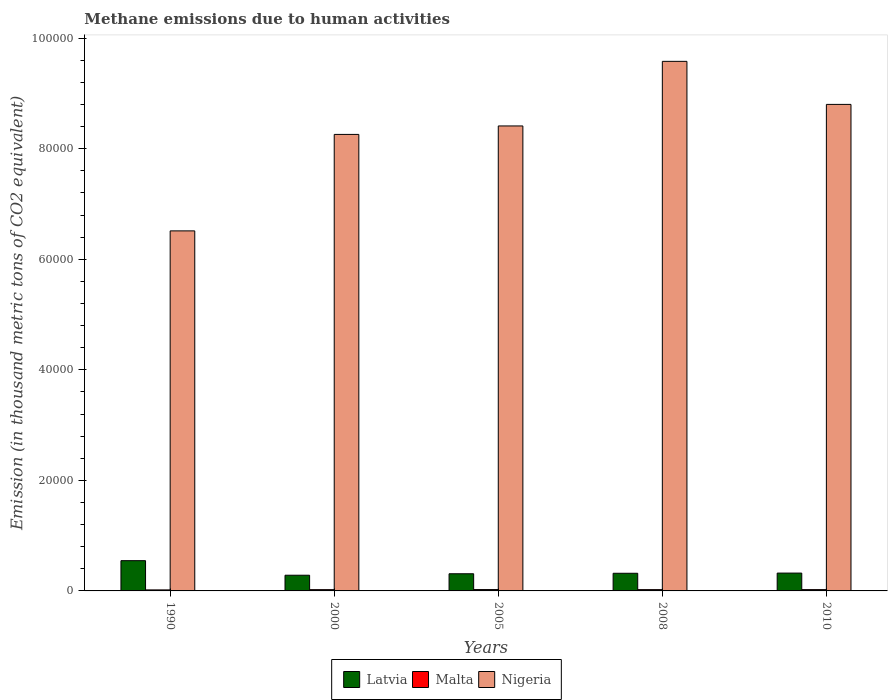How many different coloured bars are there?
Your answer should be very brief. 3. Are the number of bars per tick equal to the number of legend labels?
Offer a terse response. Yes. In how many cases, is the number of bars for a given year not equal to the number of legend labels?
Keep it short and to the point. 0. What is the amount of methane emitted in Malta in 2000?
Give a very brief answer. 230.8. Across all years, what is the maximum amount of methane emitted in Nigeria?
Give a very brief answer. 9.58e+04. Across all years, what is the minimum amount of methane emitted in Latvia?
Ensure brevity in your answer.  2840. In which year was the amount of methane emitted in Nigeria maximum?
Keep it short and to the point. 2008. In which year was the amount of methane emitted in Nigeria minimum?
Make the answer very short. 1990. What is the total amount of methane emitted in Nigeria in the graph?
Keep it short and to the point. 4.16e+05. What is the difference between the amount of methane emitted in Latvia in 2008 and that in 2010?
Your response must be concise. -35.3. What is the difference between the amount of methane emitted in Malta in 2005 and the amount of methane emitted in Latvia in 1990?
Your answer should be very brief. -5227.7. What is the average amount of methane emitted in Latvia per year?
Keep it short and to the point. 3567.46. In the year 2010, what is the difference between the amount of methane emitted in Latvia and amount of methane emitted in Malta?
Offer a very short reply. 2992. What is the ratio of the amount of methane emitted in Nigeria in 2008 to that in 2010?
Provide a succinct answer. 1.09. Is the difference between the amount of methane emitted in Latvia in 2005 and 2008 greater than the difference between the amount of methane emitted in Malta in 2005 and 2008?
Ensure brevity in your answer.  No. What is the difference between the highest and the second highest amount of methane emitted in Nigeria?
Your answer should be very brief. 7786.3. What is the difference between the highest and the lowest amount of methane emitted in Latvia?
Give a very brief answer. 2632.8. In how many years, is the amount of methane emitted in Latvia greater than the average amount of methane emitted in Latvia taken over all years?
Your response must be concise. 1. What does the 1st bar from the left in 2000 represents?
Offer a very short reply. Latvia. What does the 1st bar from the right in 2000 represents?
Offer a very short reply. Nigeria. Is it the case that in every year, the sum of the amount of methane emitted in Latvia and amount of methane emitted in Malta is greater than the amount of methane emitted in Nigeria?
Provide a short and direct response. No. Are all the bars in the graph horizontal?
Keep it short and to the point. No. How many years are there in the graph?
Ensure brevity in your answer.  5. What is the difference between two consecutive major ticks on the Y-axis?
Your answer should be compact. 2.00e+04. Are the values on the major ticks of Y-axis written in scientific E-notation?
Your answer should be compact. No. What is the title of the graph?
Give a very brief answer. Methane emissions due to human activities. What is the label or title of the Y-axis?
Your response must be concise. Emission (in thousand metric tons of CO2 equivalent). What is the Emission (in thousand metric tons of CO2 equivalent) in Latvia in 1990?
Your response must be concise. 5472.8. What is the Emission (in thousand metric tons of CO2 equivalent) of Malta in 1990?
Offer a very short reply. 183.7. What is the Emission (in thousand metric tons of CO2 equivalent) of Nigeria in 1990?
Your answer should be very brief. 6.51e+04. What is the Emission (in thousand metric tons of CO2 equivalent) of Latvia in 2000?
Your answer should be very brief. 2840. What is the Emission (in thousand metric tons of CO2 equivalent) of Malta in 2000?
Make the answer very short. 230.8. What is the Emission (in thousand metric tons of CO2 equivalent) in Nigeria in 2000?
Your response must be concise. 8.26e+04. What is the Emission (in thousand metric tons of CO2 equivalent) of Latvia in 2005?
Provide a succinct answer. 3105. What is the Emission (in thousand metric tons of CO2 equivalent) in Malta in 2005?
Your response must be concise. 245.1. What is the Emission (in thousand metric tons of CO2 equivalent) in Nigeria in 2005?
Give a very brief answer. 8.41e+04. What is the Emission (in thousand metric tons of CO2 equivalent) of Latvia in 2008?
Your answer should be very brief. 3192.1. What is the Emission (in thousand metric tons of CO2 equivalent) of Malta in 2008?
Provide a succinct answer. 234.5. What is the Emission (in thousand metric tons of CO2 equivalent) of Nigeria in 2008?
Give a very brief answer. 9.58e+04. What is the Emission (in thousand metric tons of CO2 equivalent) of Latvia in 2010?
Ensure brevity in your answer.  3227.4. What is the Emission (in thousand metric tons of CO2 equivalent) of Malta in 2010?
Offer a very short reply. 235.4. What is the Emission (in thousand metric tons of CO2 equivalent) of Nigeria in 2010?
Provide a succinct answer. 8.80e+04. Across all years, what is the maximum Emission (in thousand metric tons of CO2 equivalent) of Latvia?
Ensure brevity in your answer.  5472.8. Across all years, what is the maximum Emission (in thousand metric tons of CO2 equivalent) of Malta?
Offer a terse response. 245.1. Across all years, what is the maximum Emission (in thousand metric tons of CO2 equivalent) in Nigeria?
Keep it short and to the point. 9.58e+04. Across all years, what is the minimum Emission (in thousand metric tons of CO2 equivalent) in Latvia?
Make the answer very short. 2840. Across all years, what is the minimum Emission (in thousand metric tons of CO2 equivalent) of Malta?
Ensure brevity in your answer.  183.7. Across all years, what is the minimum Emission (in thousand metric tons of CO2 equivalent) in Nigeria?
Provide a short and direct response. 6.51e+04. What is the total Emission (in thousand metric tons of CO2 equivalent) in Latvia in the graph?
Provide a short and direct response. 1.78e+04. What is the total Emission (in thousand metric tons of CO2 equivalent) in Malta in the graph?
Your answer should be compact. 1129.5. What is the total Emission (in thousand metric tons of CO2 equivalent) in Nigeria in the graph?
Your answer should be compact. 4.16e+05. What is the difference between the Emission (in thousand metric tons of CO2 equivalent) in Latvia in 1990 and that in 2000?
Provide a short and direct response. 2632.8. What is the difference between the Emission (in thousand metric tons of CO2 equivalent) in Malta in 1990 and that in 2000?
Your answer should be compact. -47.1. What is the difference between the Emission (in thousand metric tons of CO2 equivalent) of Nigeria in 1990 and that in 2000?
Offer a very short reply. -1.75e+04. What is the difference between the Emission (in thousand metric tons of CO2 equivalent) in Latvia in 1990 and that in 2005?
Provide a short and direct response. 2367.8. What is the difference between the Emission (in thousand metric tons of CO2 equivalent) in Malta in 1990 and that in 2005?
Offer a very short reply. -61.4. What is the difference between the Emission (in thousand metric tons of CO2 equivalent) of Nigeria in 1990 and that in 2005?
Ensure brevity in your answer.  -1.90e+04. What is the difference between the Emission (in thousand metric tons of CO2 equivalent) of Latvia in 1990 and that in 2008?
Your response must be concise. 2280.7. What is the difference between the Emission (in thousand metric tons of CO2 equivalent) in Malta in 1990 and that in 2008?
Give a very brief answer. -50.8. What is the difference between the Emission (in thousand metric tons of CO2 equivalent) in Nigeria in 1990 and that in 2008?
Ensure brevity in your answer.  -3.07e+04. What is the difference between the Emission (in thousand metric tons of CO2 equivalent) of Latvia in 1990 and that in 2010?
Offer a very short reply. 2245.4. What is the difference between the Emission (in thousand metric tons of CO2 equivalent) of Malta in 1990 and that in 2010?
Your answer should be compact. -51.7. What is the difference between the Emission (in thousand metric tons of CO2 equivalent) of Nigeria in 1990 and that in 2010?
Your response must be concise. -2.29e+04. What is the difference between the Emission (in thousand metric tons of CO2 equivalent) in Latvia in 2000 and that in 2005?
Keep it short and to the point. -265. What is the difference between the Emission (in thousand metric tons of CO2 equivalent) of Malta in 2000 and that in 2005?
Offer a very short reply. -14.3. What is the difference between the Emission (in thousand metric tons of CO2 equivalent) of Nigeria in 2000 and that in 2005?
Give a very brief answer. -1533.6. What is the difference between the Emission (in thousand metric tons of CO2 equivalent) of Latvia in 2000 and that in 2008?
Provide a short and direct response. -352.1. What is the difference between the Emission (in thousand metric tons of CO2 equivalent) in Nigeria in 2000 and that in 2008?
Provide a succinct answer. -1.32e+04. What is the difference between the Emission (in thousand metric tons of CO2 equivalent) in Latvia in 2000 and that in 2010?
Your response must be concise. -387.4. What is the difference between the Emission (in thousand metric tons of CO2 equivalent) in Malta in 2000 and that in 2010?
Offer a very short reply. -4.6. What is the difference between the Emission (in thousand metric tons of CO2 equivalent) in Nigeria in 2000 and that in 2010?
Give a very brief answer. -5432.6. What is the difference between the Emission (in thousand metric tons of CO2 equivalent) in Latvia in 2005 and that in 2008?
Your answer should be compact. -87.1. What is the difference between the Emission (in thousand metric tons of CO2 equivalent) of Malta in 2005 and that in 2008?
Keep it short and to the point. 10.6. What is the difference between the Emission (in thousand metric tons of CO2 equivalent) of Nigeria in 2005 and that in 2008?
Provide a succinct answer. -1.17e+04. What is the difference between the Emission (in thousand metric tons of CO2 equivalent) of Latvia in 2005 and that in 2010?
Your answer should be very brief. -122.4. What is the difference between the Emission (in thousand metric tons of CO2 equivalent) in Nigeria in 2005 and that in 2010?
Your response must be concise. -3899. What is the difference between the Emission (in thousand metric tons of CO2 equivalent) in Latvia in 2008 and that in 2010?
Provide a succinct answer. -35.3. What is the difference between the Emission (in thousand metric tons of CO2 equivalent) in Malta in 2008 and that in 2010?
Make the answer very short. -0.9. What is the difference between the Emission (in thousand metric tons of CO2 equivalent) of Nigeria in 2008 and that in 2010?
Provide a short and direct response. 7786.3. What is the difference between the Emission (in thousand metric tons of CO2 equivalent) in Latvia in 1990 and the Emission (in thousand metric tons of CO2 equivalent) in Malta in 2000?
Ensure brevity in your answer.  5242. What is the difference between the Emission (in thousand metric tons of CO2 equivalent) of Latvia in 1990 and the Emission (in thousand metric tons of CO2 equivalent) of Nigeria in 2000?
Your response must be concise. -7.71e+04. What is the difference between the Emission (in thousand metric tons of CO2 equivalent) of Malta in 1990 and the Emission (in thousand metric tons of CO2 equivalent) of Nigeria in 2000?
Provide a short and direct response. -8.24e+04. What is the difference between the Emission (in thousand metric tons of CO2 equivalent) in Latvia in 1990 and the Emission (in thousand metric tons of CO2 equivalent) in Malta in 2005?
Your answer should be compact. 5227.7. What is the difference between the Emission (in thousand metric tons of CO2 equivalent) in Latvia in 1990 and the Emission (in thousand metric tons of CO2 equivalent) in Nigeria in 2005?
Give a very brief answer. -7.86e+04. What is the difference between the Emission (in thousand metric tons of CO2 equivalent) in Malta in 1990 and the Emission (in thousand metric tons of CO2 equivalent) in Nigeria in 2005?
Your answer should be compact. -8.39e+04. What is the difference between the Emission (in thousand metric tons of CO2 equivalent) of Latvia in 1990 and the Emission (in thousand metric tons of CO2 equivalent) of Malta in 2008?
Your response must be concise. 5238.3. What is the difference between the Emission (in thousand metric tons of CO2 equivalent) of Latvia in 1990 and the Emission (in thousand metric tons of CO2 equivalent) of Nigeria in 2008?
Your response must be concise. -9.03e+04. What is the difference between the Emission (in thousand metric tons of CO2 equivalent) of Malta in 1990 and the Emission (in thousand metric tons of CO2 equivalent) of Nigeria in 2008?
Offer a terse response. -9.56e+04. What is the difference between the Emission (in thousand metric tons of CO2 equivalent) in Latvia in 1990 and the Emission (in thousand metric tons of CO2 equivalent) in Malta in 2010?
Offer a terse response. 5237.4. What is the difference between the Emission (in thousand metric tons of CO2 equivalent) of Latvia in 1990 and the Emission (in thousand metric tons of CO2 equivalent) of Nigeria in 2010?
Your answer should be very brief. -8.25e+04. What is the difference between the Emission (in thousand metric tons of CO2 equivalent) in Malta in 1990 and the Emission (in thousand metric tons of CO2 equivalent) in Nigeria in 2010?
Provide a succinct answer. -8.78e+04. What is the difference between the Emission (in thousand metric tons of CO2 equivalent) of Latvia in 2000 and the Emission (in thousand metric tons of CO2 equivalent) of Malta in 2005?
Offer a terse response. 2594.9. What is the difference between the Emission (in thousand metric tons of CO2 equivalent) in Latvia in 2000 and the Emission (in thousand metric tons of CO2 equivalent) in Nigeria in 2005?
Give a very brief answer. -8.13e+04. What is the difference between the Emission (in thousand metric tons of CO2 equivalent) in Malta in 2000 and the Emission (in thousand metric tons of CO2 equivalent) in Nigeria in 2005?
Keep it short and to the point. -8.39e+04. What is the difference between the Emission (in thousand metric tons of CO2 equivalent) of Latvia in 2000 and the Emission (in thousand metric tons of CO2 equivalent) of Malta in 2008?
Offer a very short reply. 2605.5. What is the difference between the Emission (in thousand metric tons of CO2 equivalent) in Latvia in 2000 and the Emission (in thousand metric tons of CO2 equivalent) in Nigeria in 2008?
Provide a succinct answer. -9.30e+04. What is the difference between the Emission (in thousand metric tons of CO2 equivalent) in Malta in 2000 and the Emission (in thousand metric tons of CO2 equivalent) in Nigeria in 2008?
Ensure brevity in your answer.  -9.56e+04. What is the difference between the Emission (in thousand metric tons of CO2 equivalent) in Latvia in 2000 and the Emission (in thousand metric tons of CO2 equivalent) in Malta in 2010?
Keep it short and to the point. 2604.6. What is the difference between the Emission (in thousand metric tons of CO2 equivalent) in Latvia in 2000 and the Emission (in thousand metric tons of CO2 equivalent) in Nigeria in 2010?
Give a very brief answer. -8.52e+04. What is the difference between the Emission (in thousand metric tons of CO2 equivalent) in Malta in 2000 and the Emission (in thousand metric tons of CO2 equivalent) in Nigeria in 2010?
Your response must be concise. -8.78e+04. What is the difference between the Emission (in thousand metric tons of CO2 equivalent) in Latvia in 2005 and the Emission (in thousand metric tons of CO2 equivalent) in Malta in 2008?
Your answer should be very brief. 2870.5. What is the difference between the Emission (in thousand metric tons of CO2 equivalent) in Latvia in 2005 and the Emission (in thousand metric tons of CO2 equivalent) in Nigeria in 2008?
Provide a short and direct response. -9.27e+04. What is the difference between the Emission (in thousand metric tons of CO2 equivalent) of Malta in 2005 and the Emission (in thousand metric tons of CO2 equivalent) of Nigeria in 2008?
Offer a very short reply. -9.56e+04. What is the difference between the Emission (in thousand metric tons of CO2 equivalent) of Latvia in 2005 and the Emission (in thousand metric tons of CO2 equivalent) of Malta in 2010?
Provide a succinct answer. 2869.6. What is the difference between the Emission (in thousand metric tons of CO2 equivalent) in Latvia in 2005 and the Emission (in thousand metric tons of CO2 equivalent) in Nigeria in 2010?
Provide a short and direct response. -8.49e+04. What is the difference between the Emission (in thousand metric tons of CO2 equivalent) in Malta in 2005 and the Emission (in thousand metric tons of CO2 equivalent) in Nigeria in 2010?
Provide a short and direct response. -8.78e+04. What is the difference between the Emission (in thousand metric tons of CO2 equivalent) in Latvia in 2008 and the Emission (in thousand metric tons of CO2 equivalent) in Malta in 2010?
Keep it short and to the point. 2956.7. What is the difference between the Emission (in thousand metric tons of CO2 equivalent) in Latvia in 2008 and the Emission (in thousand metric tons of CO2 equivalent) in Nigeria in 2010?
Offer a very short reply. -8.48e+04. What is the difference between the Emission (in thousand metric tons of CO2 equivalent) in Malta in 2008 and the Emission (in thousand metric tons of CO2 equivalent) in Nigeria in 2010?
Give a very brief answer. -8.78e+04. What is the average Emission (in thousand metric tons of CO2 equivalent) in Latvia per year?
Your answer should be very brief. 3567.46. What is the average Emission (in thousand metric tons of CO2 equivalent) of Malta per year?
Give a very brief answer. 225.9. What is the average Emission (in thousand metric tons of CO2 equivalent) of Nigeria per year?
Your response must be concise. 8.31e+04. In the year 1990, what is the difference between the Emission (in thousand metric tons of CO2 equivalent) of Latvia and Emission (in thousand metric tons of CO2 equivalent) of Malta?
Make the answer very short. 5289.1. In the year 1990, what is the difference between the Emission (in thousand metric tons of CO2 equivalent) of Latvia and Emission (in thousand metric tons of CO2 equivalent) of Nigeria?
Provide a succinct answer. -5.97e+04. In the year 1990, what is the difference between the Emission (in thousand metric tons of CO2 equivalent) in Malta and Emission (in thousand metric tons of CO2 equivalent) in Nigeria?
Make the answer very short. -6.50e+04. In the year 2000, what is the difference between the Emission (in thousand metric tons of CO2 equivalent) of Latvia and Emission (in thousand metric tons of CO2 equivalent) of Malta?
Offer a terse response. 2609.2. In the year 2000, what is the difference between the Emission (in thousand metric tons of CO2 equivalent) in Latvia and Emission (in thousand metric tons of CO2 equivalent) in Nigeria?
Ensure brevity in your answer.  -7.97e+04. In the year 2000, what is the difference between the Emission (in thousand metric tons of CO2 equivalent) in Malta and Emission (in thousand metric tons of CO2 equivalent) in Nigeria?
Give a very brief answer. -8.24e+04. In the year 2005, what is the difference between the Emission (in thousand metric tons of CO2 equivalent) in Latvia and Emission (in thousand metric tons of CO2 equivalent) in Malta?
Your answer should be compact. 2859.9. In the year 2005, what is the difference between the Emission (in thousand metric tons of CO2 equivalent) of Latvia and Emission (in thousand metric tons of CO2 equivalent) of Nigeria?
Offer a terse response. -8.10e+04. In the year 2005, what is the difference between the Emission (in thousand metric tons of CO2 equivalent) of Malta and Emission (in thousand metric tons of CO2 equivalent) of Nigeria?
Ensure brevity in your answer.  -8.39e+04. In the year 2008, what is the difference between the Emission (in thousand metric tons of CO2 equivalent) of Latvia and Emission (in thousand metric tons of CO2 equivalent) of Malta?
Offer a terse response. 2957.6. In the year 2008, what is the difference between the Emission (in thousand metric tons of CO2 equivalent) of Latvia and Emission (in thousand metric tons of CO2 equivalent) of Nigeria?
Ensure brevity in your answer.  -9.26e+04. In the year 2008, what is the difference between the Emission (in thousand metric tons of CO2 equivalent) in Malta and Emission (in thousand metric tons of CO2 equivalent) in Nigeria?
Your response must be concise. -9.56e+04. In the year 2010, what is the difference between the Emission (in thousand metric tons of CO2 equivalent) of Latvia and Emission (in thousand metric tons of CO2 equivalent) of Malta?
Your answer should be compact. 2992. In the year 2010, what is the difference between the Emission (in thousand metric tons of CO2 equivalent) in Latvia and Emission (in thousand metric tons of CO2 equivalent) in Nigeria?
Provide a succinct answer. -8.48e+04. In the year 2010, what is the difference between the Emission (in thousand metric tons of CO2 equivalent) in Malta and Emission (in thousand metric tons of CO2 equivalent) in Nigeria?
Make the answer very short. -8.78e+04. What is the ratio of the Emission (in thousand metric tons of CO2 equivalent) in Latvia in 1990 to that in 2000?
Make the answer very short. 1.93. What is the ratio of the Emission (in thousand metric tons of CO2 equivalent) of Malta in 1990 to that in 2000?
Provide a short and direct response. 0.8. What is the ratio of the Emission (in thousand metric tons of CO2 equivalent) of Nigeria in 1990 to that in 2000?
Your response must be concise. 0.79. What is the ratio of the Emission (in thousand metric tons of CO2 equivalent) in Latvia in 1990 to that in 2005?
Offer a very short reply. 1.76. What is the ratio of the Emission (in thousand metric tons of CO2 equivalent) in Malta in 1990 to that in 2005?
Provide a short and direct response. 0.75. What is the ratio of the Emission (in thousand metric tons of CO2 equivalent) in Nigeria in 1990 to that in 2005?
Provide a succinct answer. 0.77. What is the ratio of the Emission (in thousand metric tons of CO2 equivalent) of Latvia in 1990 to that in 2008?
Ensure brevity in your answer.  1.71. What is the ratio of the Emission (in thousand metric tons of CO2 equivalent) in Malta in 1990 to that in 2008?
Provide a succinct answer. 0.78. What is the ratio of the Emission (in thousand metric tons of CO2 equivalent) in Nigeria in 1990 to that in 2008?
Give a very brief answer. 0.68. What is the ratio of the Emission (in thousand metric tons of CO2 equivalent) in Latvia in 1990 to that in 2010?
Provide a short and direct response. 1.7. What is the ratio of the Emission (in thousand metric tons of CO2 equivalent) in Malta in 1990 to that in 2010?
Your answer should be very brief. 0.78. What is the ratio of the Emission (in thousand metric tons of CO2 equivalent) in Nigeria in 1990 to that in 2010?
Provide a succinct answer. 0.74. What is the ratio of the Emission (in thousand metric tons of CO2 equivalent) in Latvia in 2000 to that in 2005?
Make the answer very short. 0.91. What is the ratio of the Emission (in thousand metric tons of CO2 equivalent) of Malta in 2000 to that in 2005?
Keep it short and to the point. 0.94. What is the ratio of the Emission (in thousand metric tons of CO2 equivalent) of Nigeria in 2000 to that in 2005?
Provide a succinct answer. 0.98. What is the ratio of the Emission (in thousand metric tons of CO2 equivalent) of Latvia in 2000 to that in 2008?
Give a very brief answer. 0.89. What is the ratio of the Emission (in thousand metric tons of CO2 equivalent) in Malta in 2000 to that in 2008?
Give a very brief answer. 0.98. What is the ratio of the Emission (in thousand metric tons of CO2 equivalent) of Nigeria in 2000 to that in 2008?
Offer a terse response. 0.86. What is the ratio of the Emission (in thousand metric tons of CO2 equivalent) of Latvia in 2000 to that in 2010?
Give a very brief answer. 0.88. What is the ratio of the Emission (in thousand metric tons of CO2 equivalent) of Malta in 2000 to that in 2010?
Offer a very short reply. 0.98. What is the ratio of the Emission (in thousand metric tons of CO2 equivalent) in Nigeria in 2000 to that in 2010?
Your response must be concise. 0.94. What is the ratio of the Emission (in thousand metric tons of CO2 equivalent) of Latvia in 2005 to that in 2008?
Your answer should be very brief. 0.97. What is the ratio of the Emission (in thousand metric tons of CO2 equivalent) in Malta in 2005 to that in 2008?
Give a very brief answer. 1.05. What is the ratio of the Emission (in thousand metric tons of CO2 equivalent) in Nigeria in 2005 to that in 2008?
Ensure brevity in your answer.  0.88. What is the ratio of the Emission (in thousand metric tons of CO2 equivalent) in Latvia in 2005 to that in 2010?
Your response must be concise. 0.96. What is the ratio of the Emission (in thousand metric tons of CO2 equivalent) of Malta in 2005 to that in 2010?
Your response must be concise. 1.04. What is the ratio of the Emission (in thousand metric tons of CO2 equivalent) in Nigeria in 2005 to that in 2010?
Ensure brevity in your answer.  0.96. What is the ratio of the Emission (in thousand metric tons of CO2 equivalent) of Latvia in 2008 to that in 2010?
Provide a short and direct response. 0.99. What is the ratio of the Emission (in thousand metric tons of CO2 equivalent) in Malta in 2008 to that in 2010?
Your answer should be very brief. 1. What is the ratio of the Emission (in thousand metric tons of CO2 equivalent) in Nigeria in 2008 to that in 2010?
Offer a terse response. 1.09. What is the difference between the highest and the second highest Emission (in thousand metric tons of CO2 equivalent) in Latvia?
Give a very brief answer. 2245.4. What is the difference between the highest and the second highest Emission (in thousand metric tons of CO2 equivalent) in Malta?
Your answer should be compact. 9.7. What is the difference between the highest and the second highest Emission (in thousand metric tons of CO2 equivalent) of Nigeria?
Provide a short and direct response. 7786.3. What is the difference between the highest and the lowest Emission (in thousand metric tons of CO2 equivalent) in Latvia?
Give a very brief answer. 2632.8. What is the difference between the highest and the lowest Emission (in thousand metric tons of CO2 equivalent) in Malta?
Keep it short and to the point. 61.4. What is the difference between the highest and the lowest Emission (in thousand metric tons of CO2 equivalent) of Nigeria?
Provide a succinct answer. 3.07e+04. 